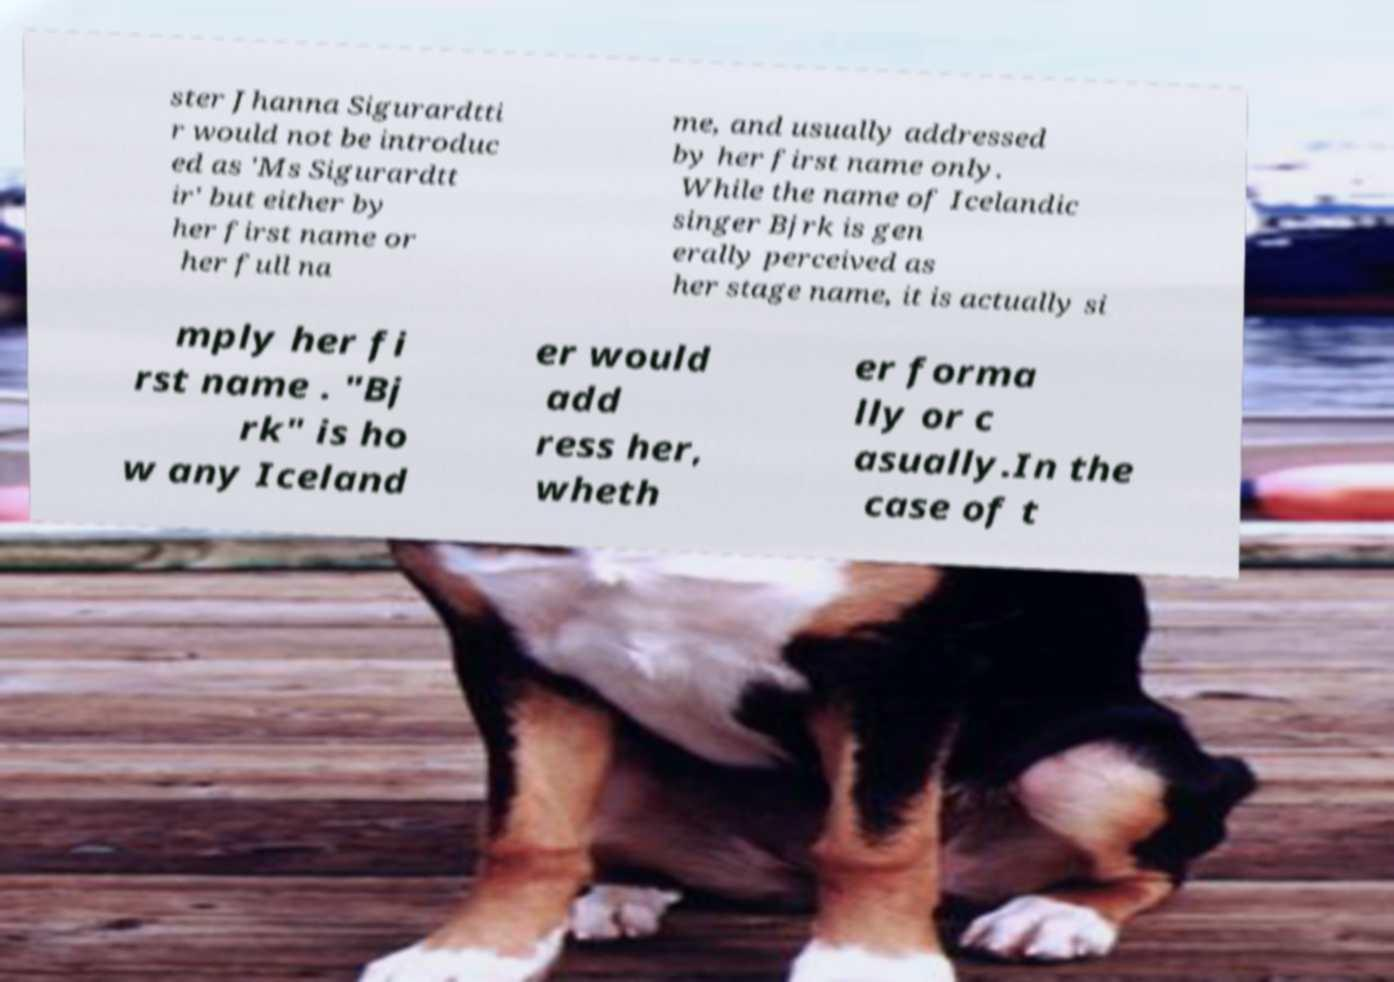For documentation purposes, I need the text within this image transcribed. Could you provide that? ster Jhanna Sigurardtti r would not be introduc ed as 'Ms Sigurardtt ir' but either by her first name or her full na me, and usually addressed by her first name only. While the name of Icelandic singer Bjrk is gen erally perceived as her stage name, it is actually si mply her fi rst name . "Bj rk" is ho w any Iceland er would add ress her, wheth er forma lly or c asually.In the case of t 